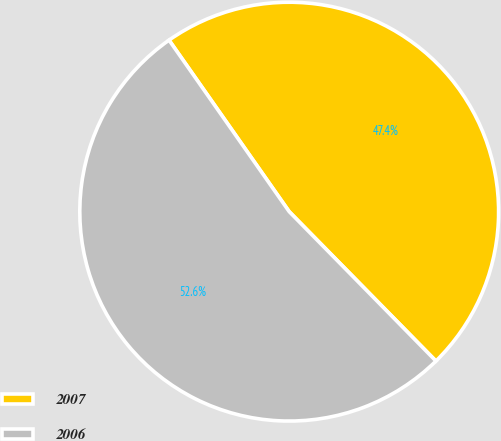Convert chart to OTSL. <chart><loc_0><loc_0><loc_500><loc_500><pie_chart><fcel>2007<fcel>2006<nl><fcel>47.37%<fcel>52.63%<nl></chart> 